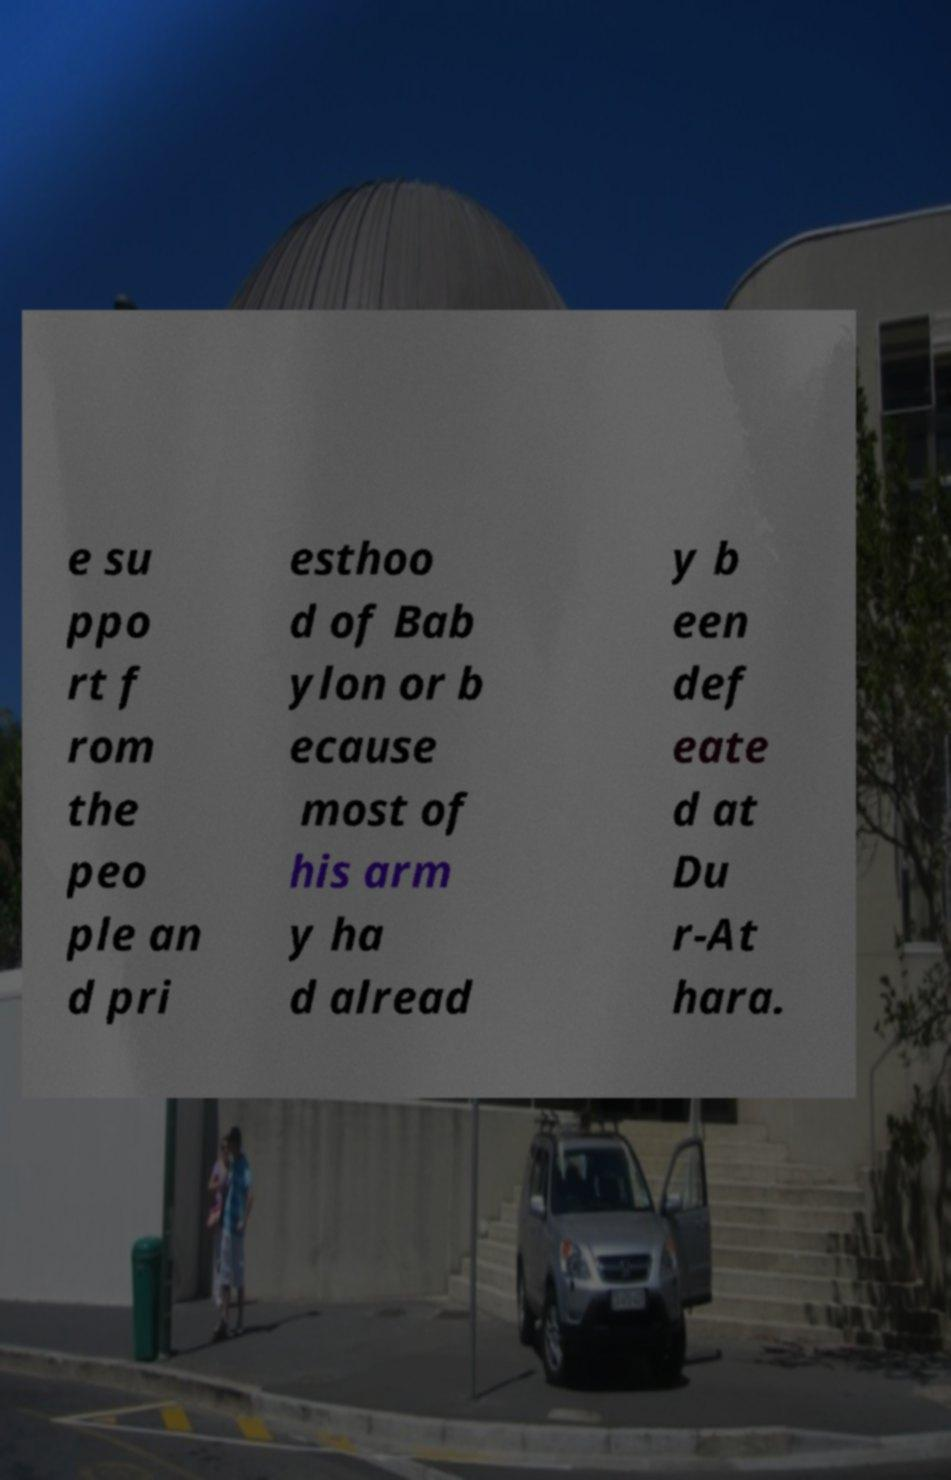Please identify and transcribe the text found in this image. e su ppo rt f rom the peo ple an d pri esthoo d of Bab ylon or b ecause most of his arm y ha d alread y b een def eate d at Du r-At hara. 